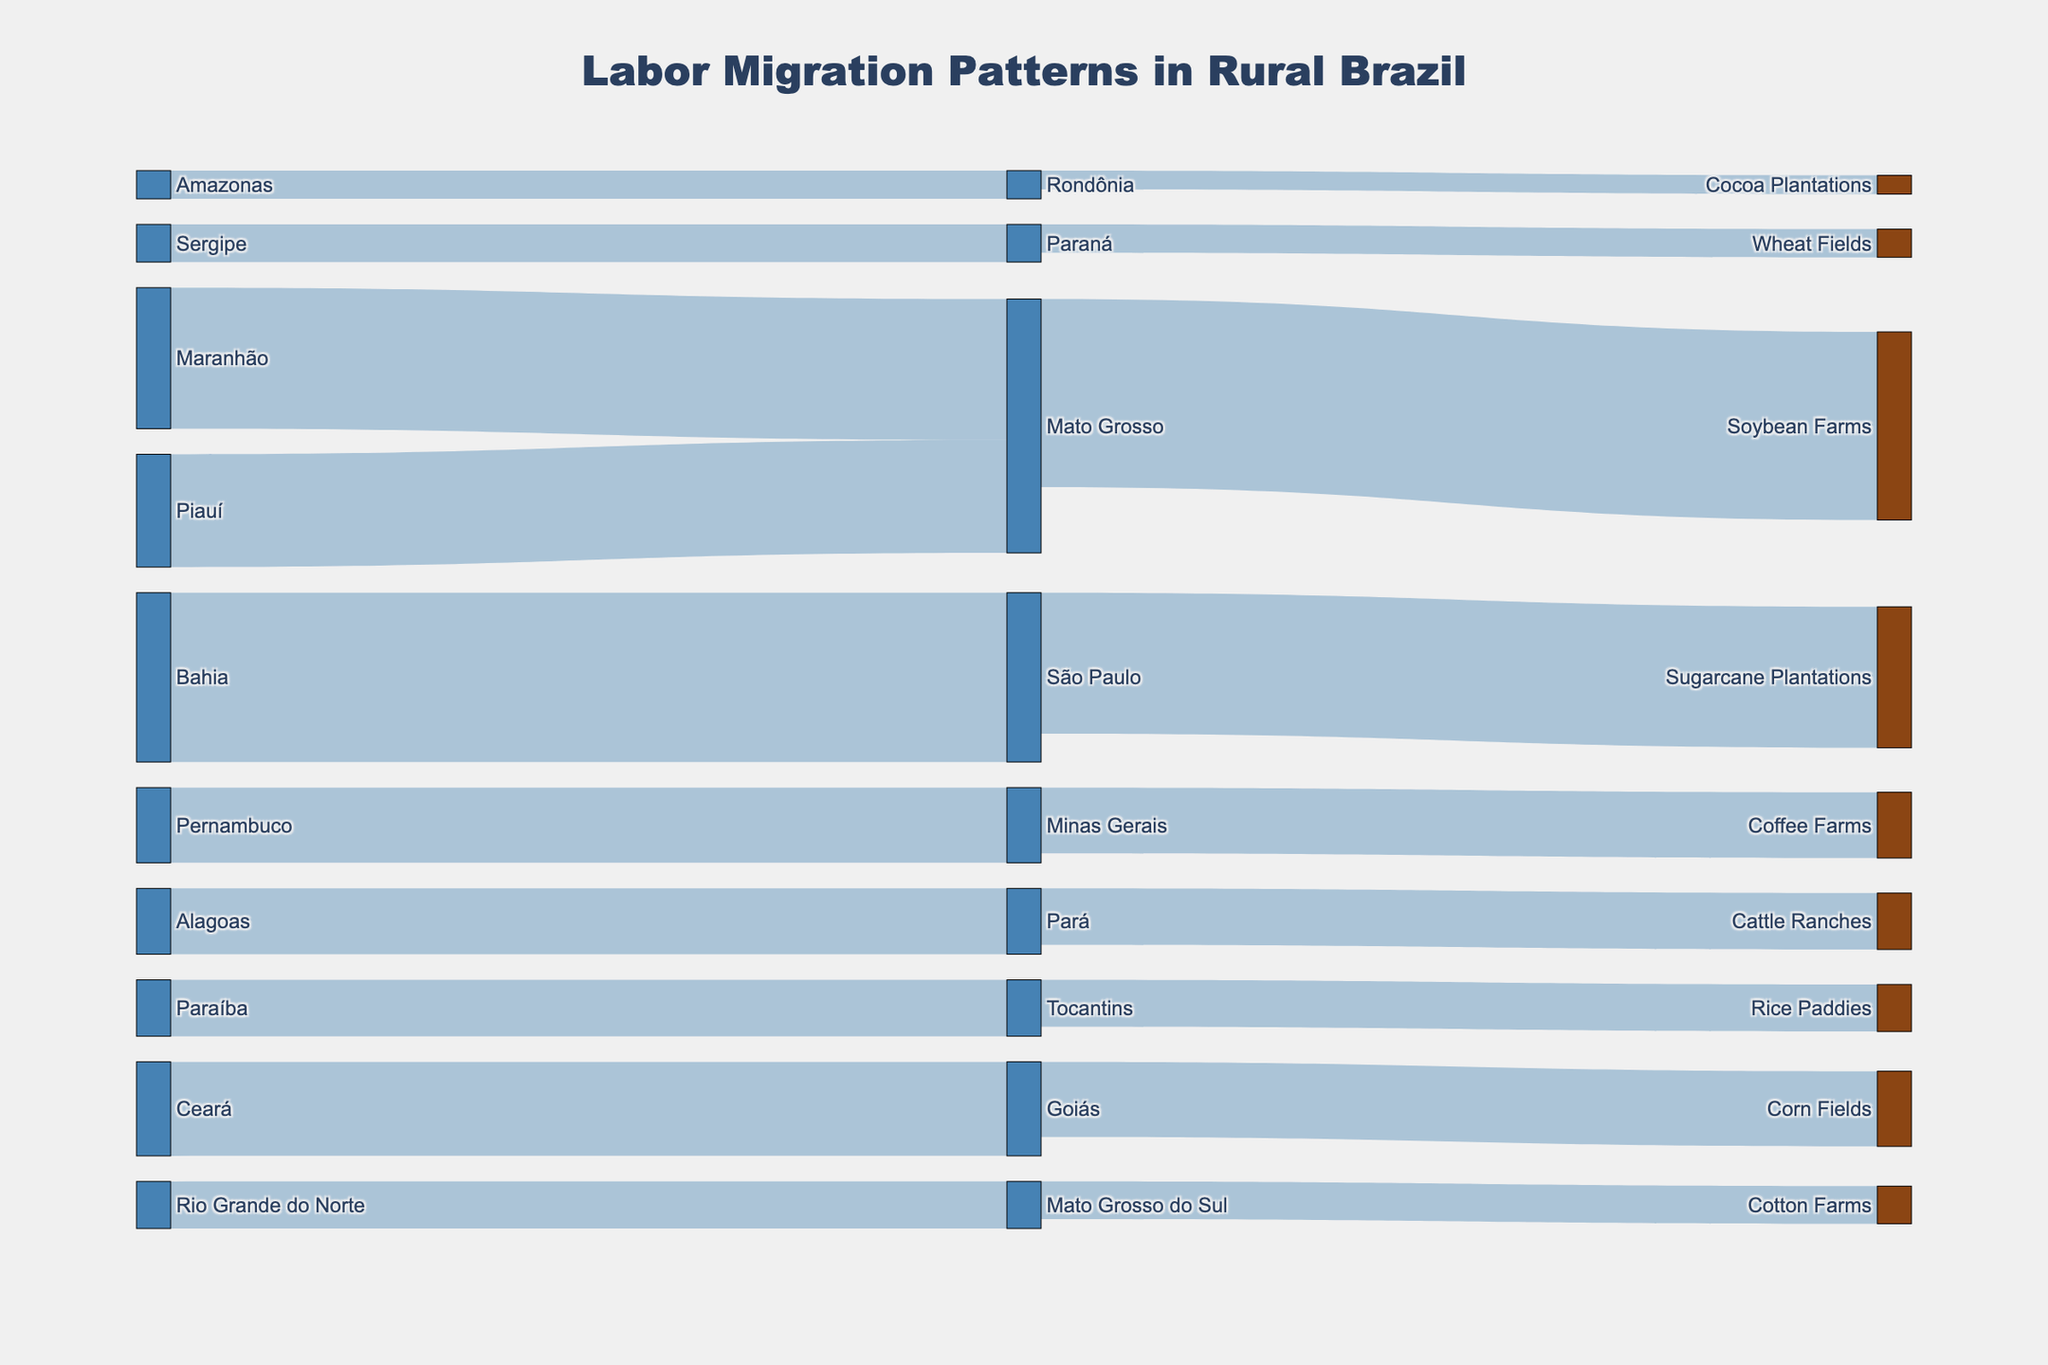What is the title of the figure? The title is usually displayed at the top of the figure and provides a summary of what the figure represents. In this case, the title is "Labor Migration Patterns in Rural Brazil."
Answer: Labor Migration Patterns in Rural Brazil Which source region has the highest migration to Mato Grosso? To find out which region has the highest migration to Mato Grosso, look at the links connecting to Mato Grosso and compare the values. Maranhão has the highest migration with 15,000.
Answer: Maranhão How many people migrated from Bahia to São Paulo? Check the link connecting Bahia to São Paulo. The label on this link indicates the number of people. Here, 18,000 people migrated from Bahia to São Paulo.
Answer: 18,000 What is the total labor migration to agricultural employment areas from Maranhão and Piauí? Add the migration values from Maranhão to Mato Grosso (15,000) and Piauí to Mato Grosso (12,000). The total is 15,000 + 12,000 = 27,000.
Answer: 27,000 Which agricultural employment area receives the most labor from different source regions? Compare the incoming migration values for all agricultural employment areas. The Soybean Farms in Mato Grosso receive a total of 20,000, the highest among the areas.
Answer: Soybean Farms (Mato Grosso) How many people in total migrated to coffee farms? Identify the link connecting Minas Gerais to Coffee Farms, which has a value of 7,000. This represents the total migration to Coffee Farms.
Answer: 7,000 Are there more people migrating to Sugarcane Plantations or Cocoa Plantations? Compare the migration values to these two areas. Sugarcane Plantations receive 15,000 people, while Cocoa Plantations receive 2,000. Thus, more people migrate to Sugarcane Plantations.
Answer: Sugarcane Plantations If you combine the labor migrating to Pará and Rondônia, what is their total migration value? Add the migration values for both Pará (7,000 to Pará plus 6,000 to Cattle Ranches) and Rondônia (3,000 to Cocoa Plantations). The total is 7,000 + 6,000 + 3,000 = 16,000.
Answer: 16,000 What is the combined migration from Ceará and Pernambuco? Summing the migration values from Ceará to Goiás (10,000) and Pernambuco to Minas Gerais (8,000), the total is 10,000 + 8,000 = 18,000.
Answer: 18,000 Which target destination indicated by green color in the diagram has the lowest migration value? To identify this, look for green-colored nodes that represent agricultural employment areas and compare their migration values. Cocoa Plantations have the lowest migration value of 2,000.
Answer: Cocoa Plantations 